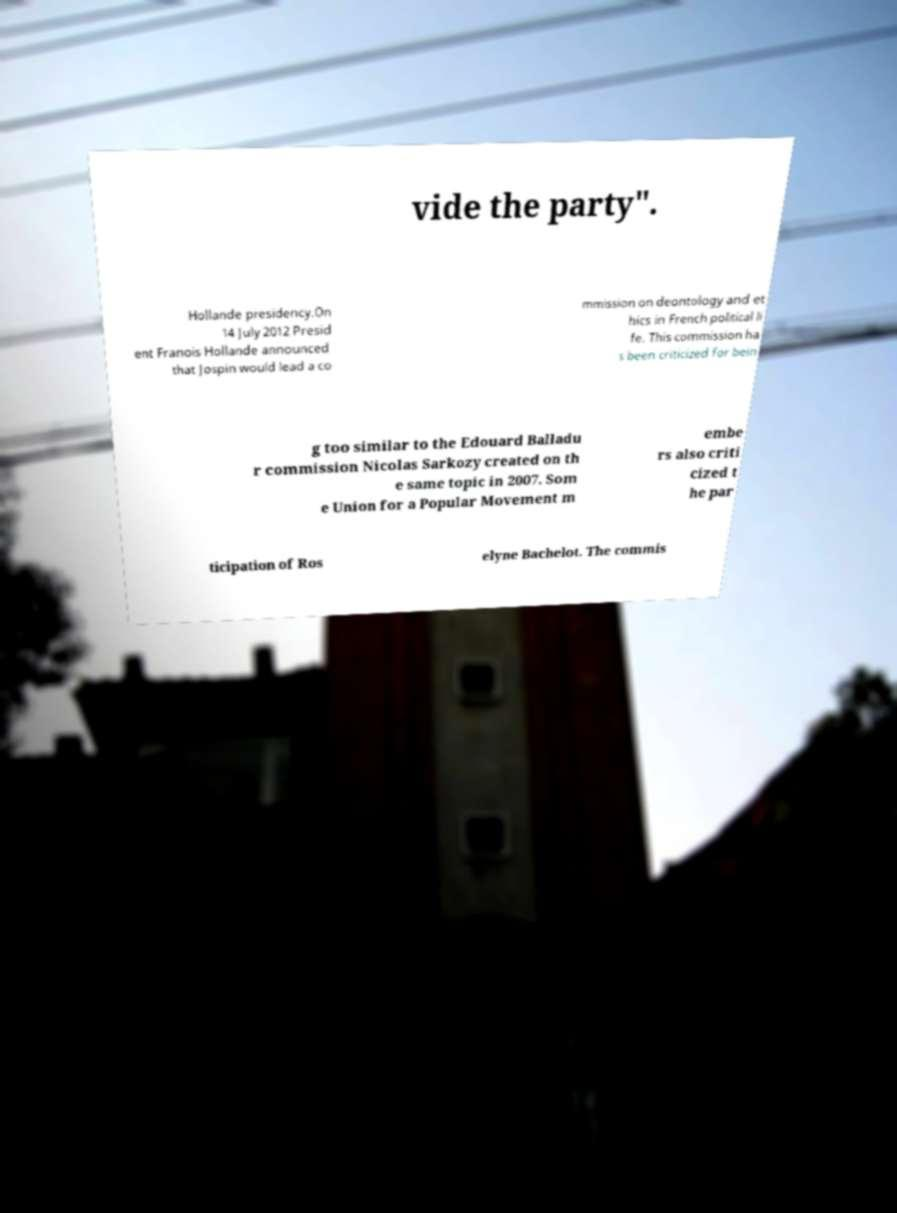Could you assist in decoding the text presented in this image and type it out clearly? vide the party". Hollande presidency.On 14 July 2012 Presid ent Franois Hollande announced that Jospin would lead a co mmission on deontology and et hics in French political li fe. This commission ha s been criticized for bein g too similar to the Edouard Balladu r commission Nicolas Sarkozy created on th e same topic in 2007. Som e Union for a Popular Movement m embe rs also criti cized t he par ticipation of Ros elyne Bachelot. The commis 